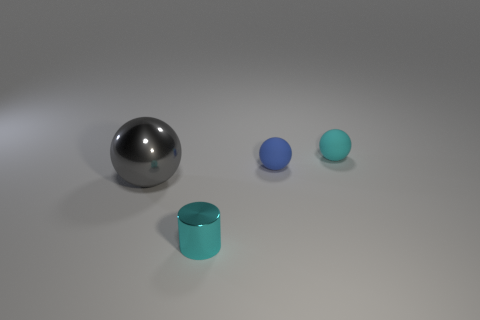What number of tiny things are behind the large metal ball and in front of the big gray sphere?
Offer a terse response. 0. How many red objects are either tiny matte things or large metallic balls?
Ensure brevity in your answer.  0. There is a sphere that is to the left of the small cyan cylinder; is it the same color as the object in front of the big metal object?
Your answer should be very brief. No. What is the color of the shiny thing behind the cyan object that is in front of the gray metallic ball behind the cyan cylinder?
Offer a very short reply. Gray. There is a large gray object on the left side of the tiny cylinder; is there a big gray sphere behind it?
Offer a very short reply. No. Do the object behind the blue thing and the cyan metallic object have the same shape?
Your answer should be compact. No. Is there anything else that is the same shape as the cyan metallic object?
Offer a very short reply. No. What number of cylinders are either blue matte things or big gray things?
Make the answer very short. 0. How many big gray metal spheres are there?
Offer a very short reply. 1. How big is the metallic thing that is in front of the object to the left of the cyan cylinder?
Offer a very short reply. Small. 